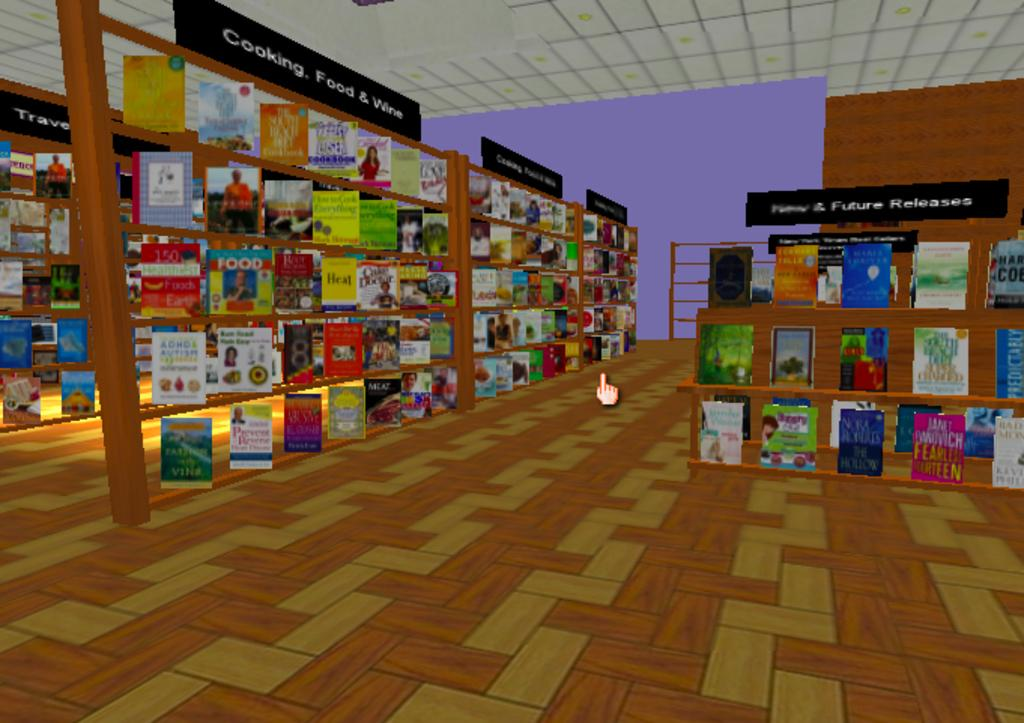What style is the image drawn in? The image is a cartoon. What objects can be seen on the shelves in the image? There are books in the shelves in the image. Can you see a person stretching in the image? There is no person present in the image, let alone stretching. What type of stamp is on the books in the image? There are no stamps on the books in the image; they are simply depicted on the shelves. 